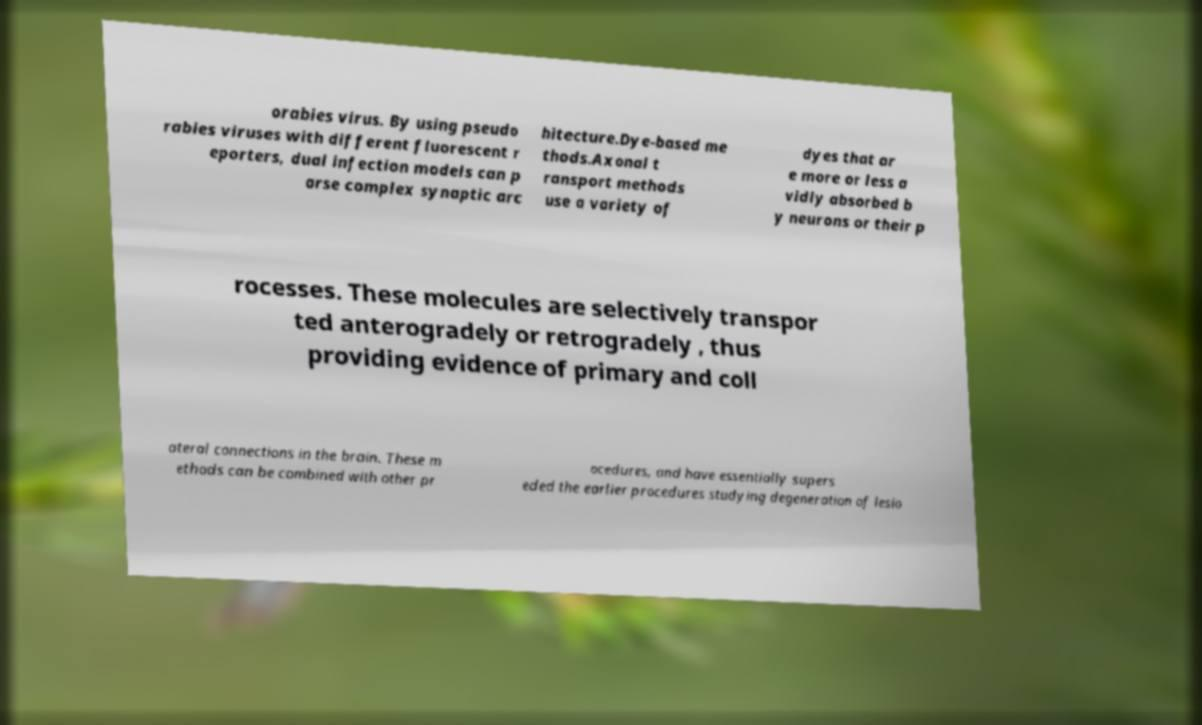Can you read and provide the text displayed in the image?This photo seems to have some interesting text. Can you extract and type it out for me? orabies virus. By using pseudo rabies viruses with different fluorescent r eporters, dual infection models can p arse complex synaptic arc hitecture.Dye-based me thods.Axonal t ransport methods use a variety of dyes that ar e more or less a vidly absorbed b y neurons or their p rocesses. These molecules are selectively transpor ted anterogradely or retrogradely , thus providing evidence of primary and coll ateral connections in the brain. These m ethods can be combined with other pr ocedures, and have essentially supers eded the earlier procedures studying degeneration of lesio 